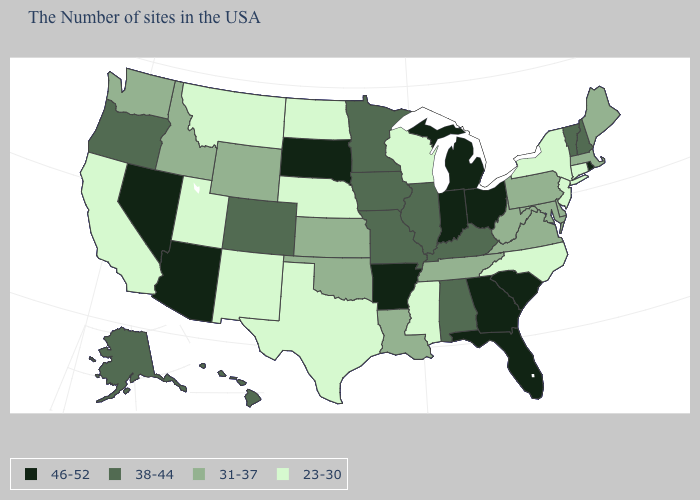What is the value of New York?
Quick response, please. 23-30. Does Wisconsin have the lowest value in the MidWest?
Concise answer only. Yes. Is the legend a continuous bar?
Keep it brief. No. Name the states that have a value in the range 31-37?
Give a very brief answer. Maine, Massachusetts, Delaware, Maryland, Pennsylvania, Virginia, West Virginia, Tennessee, Louisiana, Kansas, Oklahoma, Wyoming, Idaho, Washington. What is the value of South Dakota?
Write a very short answer. 46-52. What is the value of Vermont?
Concise answer only. 38-44. Among the states that border Tennessee , which have the highest value?
Keep it brief. Georgia, Arkansas. Does Nebraska have the lowest value in the MidWest?
Keep it brief. Yes. Among the states that border Oklahoma , does Arkansas have the highest value?
Quick response, please. Yes. What is the value of North Dakota?
Concise answer only. 23-30. What is the value of Pennsylvania?
Keep it brief. 31-37. What is the highest value in the West ?
Short answer required. 46-52. Does North Dakota have a higher value than Massachusetts?
Concise answer only. No. Name the states that have a value in the range 31-37?
Write a very short answer. Maine, Massachusetts, Delaware, Maryland, Pennsylvania, Virginia, West Virginia, Tennessee, Louisiana, Kansas, Oklahoma, Wyoming, Idaho, Washington. Does the map have missing data?
Short answer required. No. 